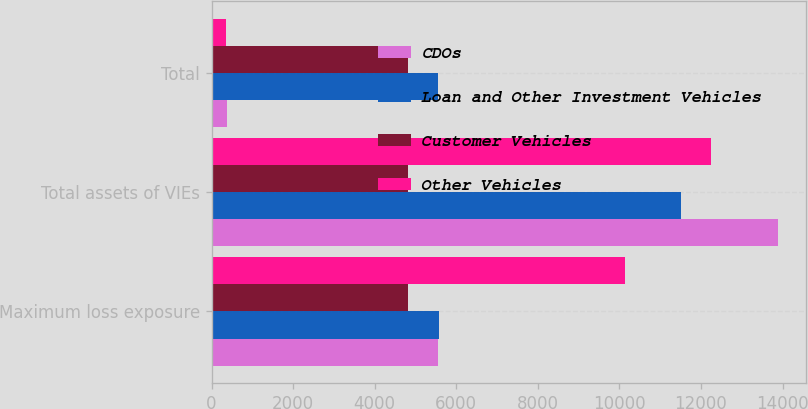<chart> <loc_0><loc_0><loc_500><loc_500><stacked_bar_chart><ecel><fcel>Maximum loss exposure<fcel>Total assets of VIEs<fcel>Total<nl><fcel>CDOs<fcel>5564<fcel>13893<fcel>378<nl><fcel>Loan and Other Investment Vehicles<fcel>5571<fcel>11507<fcel>5564<nl><fcel>Customer Vehicles<fcel>4812<fcel>4812<fcel>4812<nl><fcel>Other Vehicles<fcel>10143<fcel>12247<fcel>358<nl></chart> 